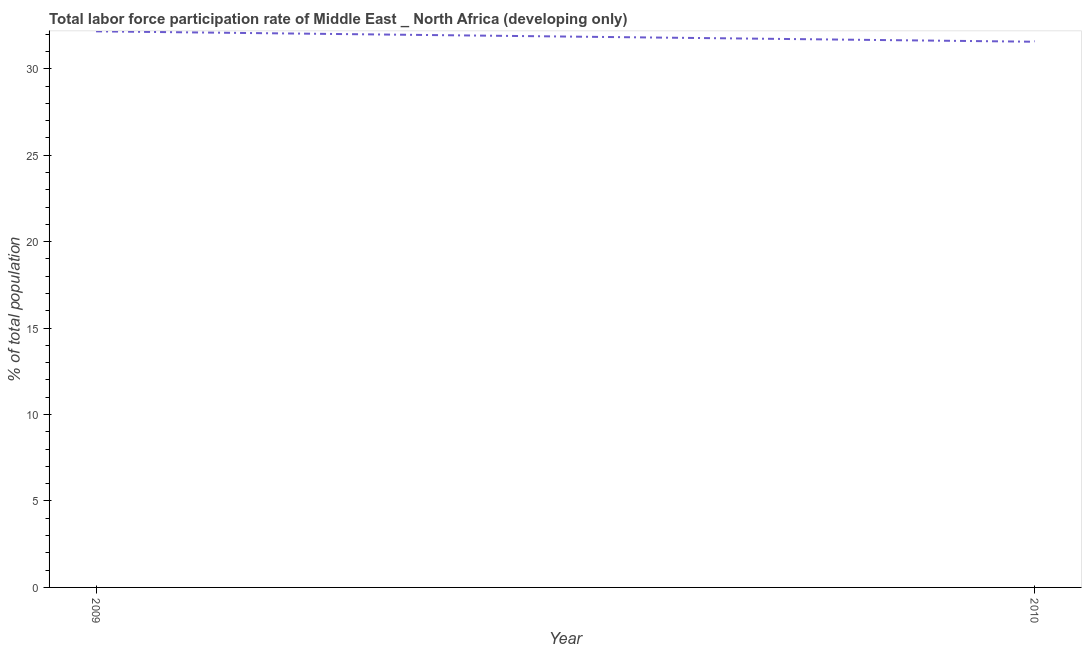What is the total labor force participation rate in 2010?
Your response must be concise. 31.57. Across all years, what is the maximum total labor force participation rate?
Give a very brief answer. 32.17. Across all years, what is the minimum total labor force participation rate?
Offer a very short reply. 31.57. What is the sum of the total labor force participation rate?
Offer a very short reply. 63.74. What is the difference between the total labor force participation rate in 2009 and 2010?
Offer a terse response. 0.6. What is the average total labor force participation rate per year?
Offer a terse response. 31.87. What is the median total labor force participation rate?
Your answer should be compact. 31.87. In how many years, is the total labor force participation rate greater than 13 %?
Keep it short and to the point. 2. What is the ratio of the total labor force participation rate in 2009 to that in 2010?
Provide a short and direct response. 1.02. Is the total labor force participation rate in 2009 less than that in 2010?
Provide a short and direct response. No. In how many years, is the total labor force participation rate greater than the average total labor force participation rate taken over all years?
Your answer should be compact. 1. How many lines are there?
Give a very brief answer. 1. What is the difference between two consecutive major ticks on the Y-axis?
Offer a terse response. 5. Are the values on the major ticks of Y-axis written in scientific E-notation?
Provide a succinct answer. No. What is the title of the graph?
Make the answer very short. Total labor force participation rate of Middle East _ North Africa (developing only). What is the label or title of the X-axis?
Your response must be concise. Year. What is the label or title of the Y-axis?
Your answer should be compact. % of total population. What is the % of total population in 2009?
Your answer should be very brief. 32.17. What is the % of total population of 2010?
Offer a terse response. 31.57. What is the difference between the % of total population in 2009 and 2010?
Offer a terse response. 0.6. 